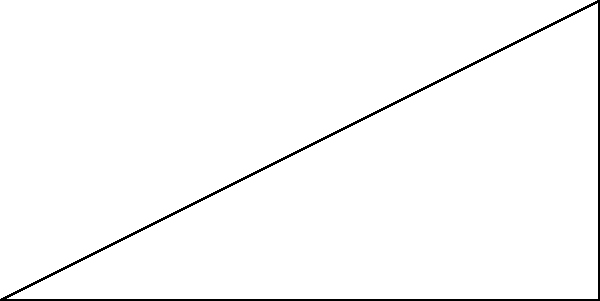You're running late for a meeting and need to quickly estimate the angle of elevation to the top of a skyscraper. The building is 90 meters tall, and you're standing 200 meters away from its base. What is the angle of elevation (rounded to the nearest degree) when you look up at the top of the building? Let's break this down step-by-step:

1) In this scenario, we have a right-angled triangle. The building forms the opposite side, and the distance from you to the building forms the adjacent side.

2) We need to find the angle $\theta$ between the ground and your line of sight to the top of the building.

3) We can use the tangent function to find this angle:

   $\tan \theta = \frac{\text{opposite}}{\text{adjacent}} = \frac{\text{height of building}}{\text{distance from building}}$

4) Plugging in the values:

   $\tan \theta = \frac{90}{200} = 0.45$

5) To find $\theta$, we need to use the inverse tangent (arctan or $\tan^{-1}$):

   $\theta = \tan^{-1}(0.45)$

6) Using a calculator (or your smartphone's calculator app for quick estimation):

   $\theta \approx 24.2^\circ$

7) Rounding to the nearest degree:

   $\theta \approx 24^\circ$
Answer: $24^\circ$ 